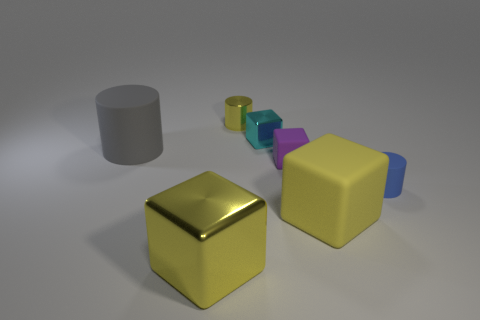How big is the thing that is to the left of the small yellow object and to the right of the large cylinder?
Keep it short and to the point. Large. Does the tiny purple thing have the same material as the yellow thing that is on the right side of the small yellow cylinder?
Your answer should be compact. Yes. What number of shiny things are the same shape as the tiny purple matte object?
Provide a short and direct response. 2. There is a large cube that is the same color as the large metallic thing; what material is it?
Keep it short and to the point. Rubber. How many green rubber things are there?
Your answer should be compact. 0. There is a tiny yellow thing; does it have the same shape as the tiny matte object that is right of the small purple block?
Your answer should be very brief. Yes. How many things are small yellow cubes or rubber objects that are in front of the purple thing?
Give a very brief answer. 2. There is a yellow thing that is the same shape as the tiny blue rubber thing; what is its material?
Provide a succinct answer. Metal. There is a big thing in front of the big yellow matte object; is its shape the same as the purple rubber thing?
Your response must be concise. Yes. Are there fewer cyan cubes to the right of the big rubber cube than cylinders to the right of the gray cylinder?
Provide a short and direct response. Yes. 